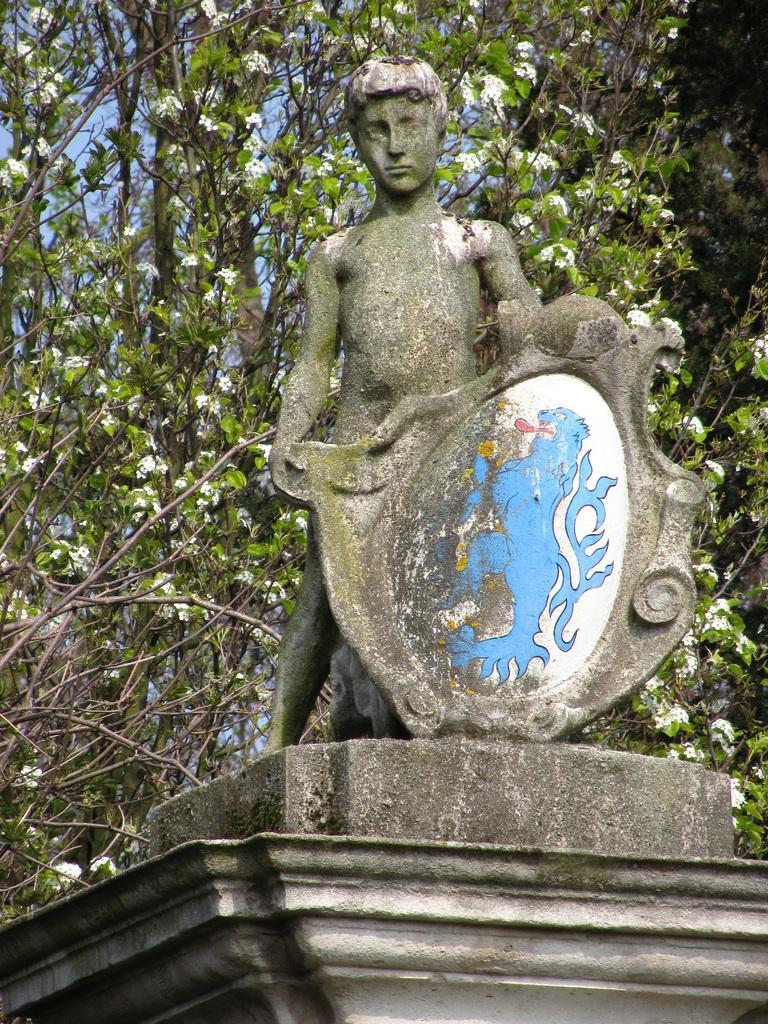Can you describe this image briefly? In this image in the center there is one statue, and at the bottom there is wall and in the background there are trees and sky. 